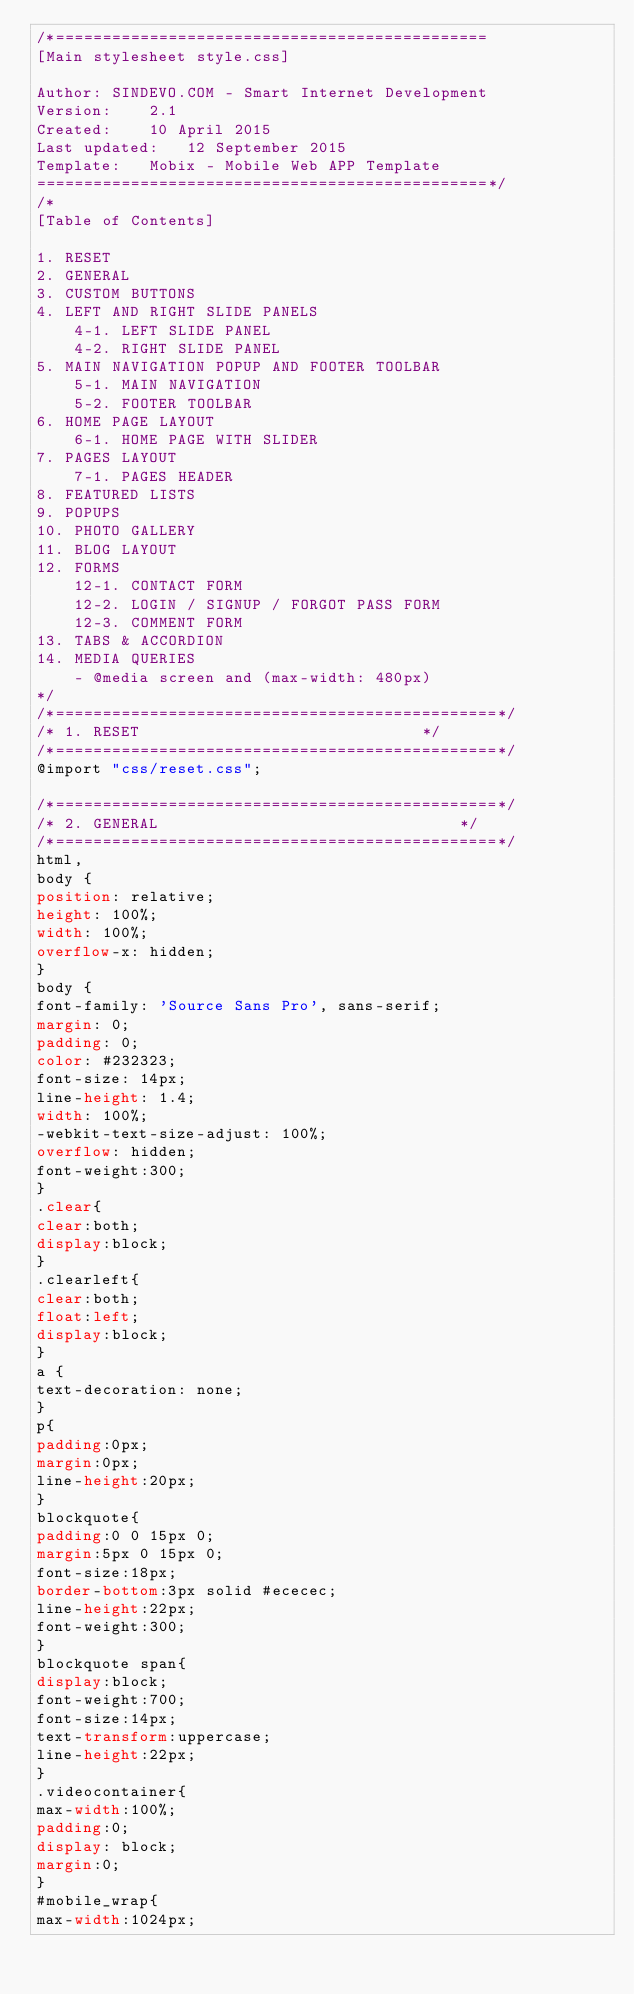Convert code to text. <code><loc_0><loc_0><loc_500><loc_500><_CSS_>/*==============================================
[Main stylesheet style.css]

Author:	SINDEVO.COM - Smart Internet Development
Version:	2.1
Created:	10 April 2015
Last updated:	12 September 2015
Template:	Mobix - Mobile Web APP Template
================================================*/
/*
[Table of Contents]

1. RESET
2. GENERAL
3. CUSTOM BUTTONS
4. LEFT AND RIGHT SLIDE PANELS
    4-1. LEFT SLIDE PANEL
	4-2. RIGHT SLIDE PANEL
5. MAIN NAVIGATION POPUP AND FOOTER TOOLBAR
	5-1. MAIN NAVIGATION
	5-2. FOOTER TOOLBAR
6. HOME PAGE LAYOUT
    6-1. HOME PAGE WITH SLIDER
7. PAGES LAYOUT
    7-1. PAGES HEADER
8. FEATURED LISTS
9. POPUPS
10. PHOTO GALLERY
11. BLOG LAYOUT
12. FORMS
	12-1. CONTACT FORM
	12-2. LOGIN / SIGNUP / FORGOT PASS FORM
	12-3. COMMENT FORM
13. TABS & ACCORDION
14. MEDIA QUERIES
    - @media screen and (max-width: 480px)
*/
/*===============================================*/
/* 1. RESET		 						 */
/*===============================================*/
@import "css/reset.css";

/*===============================================*/
/* 2. GENERAL		 						 */
/*===============================================*/	
html,
body {
position: relative;
height: 100%;
width: 100%;
overflow-x: hidden;
}
body {
font-family: 'Source Sans Pro', sans-serif;
margin: 0;
padding: 0;
color: #232323;
font-size: 14px;
line-height: 1.4;
width: 100%;
-webkit-text-size-adjust: 100%;
overflow: hidden;
font-weight:300;
}
.clear{ 
clear:both; 
display:block;
}
.clearleft{ 
clear:both; 
float:left; 
display:block;
}
a {
text-decoration: none;
}
p{
padding:0px;
margin:0px;
line-height:20px;
}
blockquote{
padding:0 0 15px 0;
margin:5px 0 15px 0;
font-size:18px;
border-bottom:3px solid #ececec;
line-height:22px;
font-weight:300;
}
blockquote span{
display:block;
font-weight:700;
font-size:14px;
text-transform:uppercase;
line-height:22px;
}
.videocontainer{
max-width:100%; 
padding:0; 
display: block; 
margin:0;
}
#mobile_wrap{
max-width:1024px;</code> 